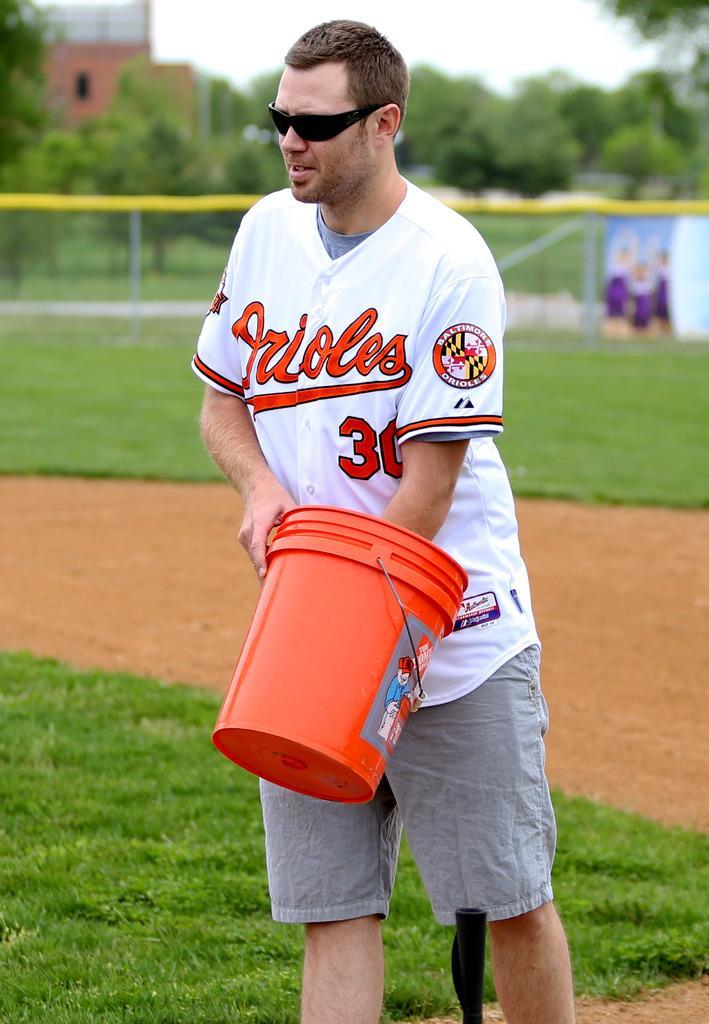In one or two sentences, can you explain what this image depicts? In the picture I can see a man is standing and holding a bucket. The man is wearing shades, at-shirt and shorts. In the background I can see the grass, fence, a building, trees, the sky and some other objects. 